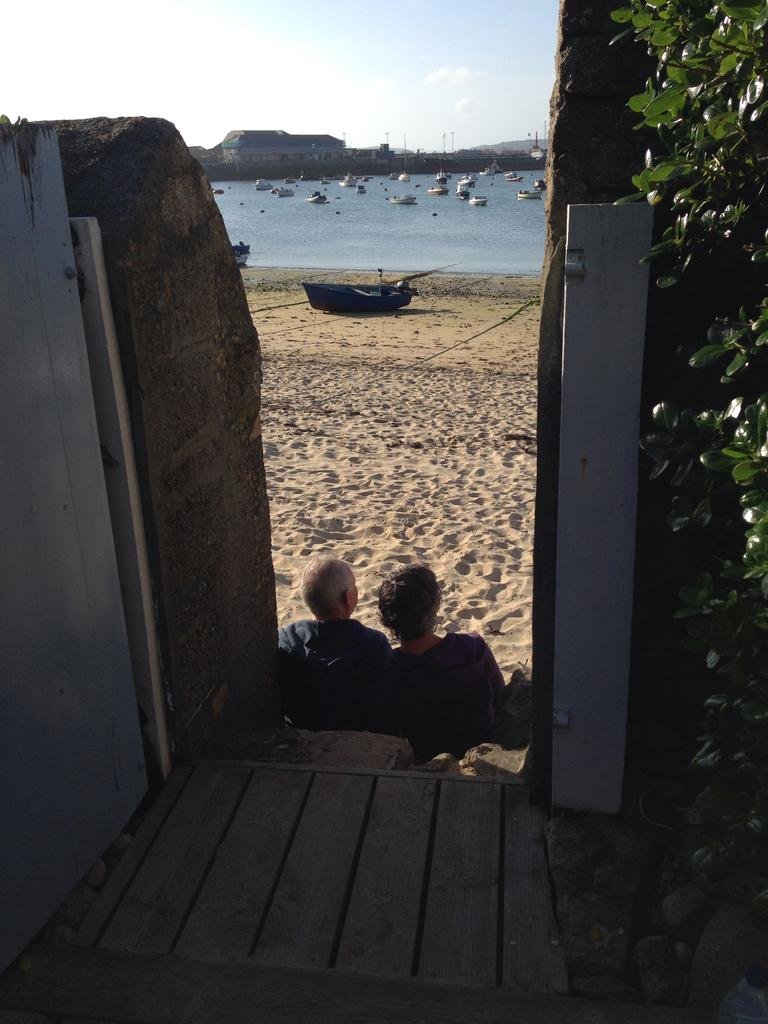How many people are sitting at the bottom of the image? There are two people sitting at the bottom of the image. What can be seen in the middle of the image? There are plants, sand, and a boat in the middle of the image. How many boats are visible in the image? There is one boat in the middle of the image, and many boats at the top of the image. What is visible at the top of the image? Water, hills, and the sky are visible at the top of the image. What can be seen in the sky? There are clouds in the sky. Can you tell me how many pens are floating in the water at the top of the image? There are no pens visible in the image; only boats, water, hills, and the sky are present. What type of ticket is required to ride the boats in the image? There is no information about tickets or boat rides in the image. 